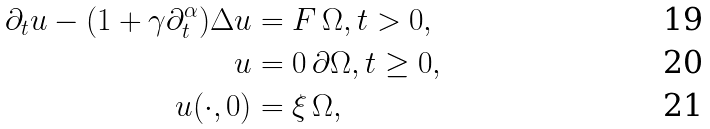Convert formula to latex. <formula><loc_0><loc_0><loc_500><loc_500>\partial _ { t } u - ( 1 + \gamma \partial _ { t } ^ { \alpha } ) \Delta u & = F \, \Omega , t > 0 , \\ u & = 0 \, \partial \Omega , t \geq 0 , \\ u ( \cdot , 0 ) & = \xi \, \Omega ,</formula> 